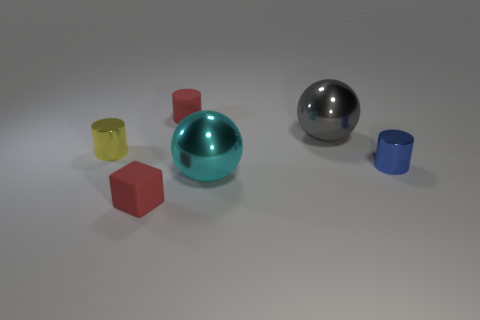There is a tiny yellow metal cylinder; are there any cyan metallic spheres in front of it?
Keep it short and to the point. Yes. Are the large cyan sphere and the red block made of the same material?
Offer a very short reply. No. What is the material of the sphere that is the same size as the gray metal thing?
Offer a very short reply. Metal. What number of objects are small cylinders behind the small yellow shiny cylinder or large metal spheres?
Offer a terse response. 3. Is the number of red objects behind the cyan metal sphere the same as the number of red matte blocks?
Your response must be concise. Yes. Is the cube the same color as the tiny rubber cylinder?
Ensure brevity in your answer.  Yes. The shiny thing that is in front of the large gray metallic object and to the right of the cyan object is what color?
Give a very brief answer. Blue. How many blocks are brown rubber things or cyan objects?
Ensure brevity in your answer.  0. Is the number of blue things that are on the right side of the blue cylinder less than the number of tiny shiny cylinders?
Your response must be concise. Yes. What shape is the large gray thing that is the same material as the yellow object?
Your answer should be compact. Sphere. 